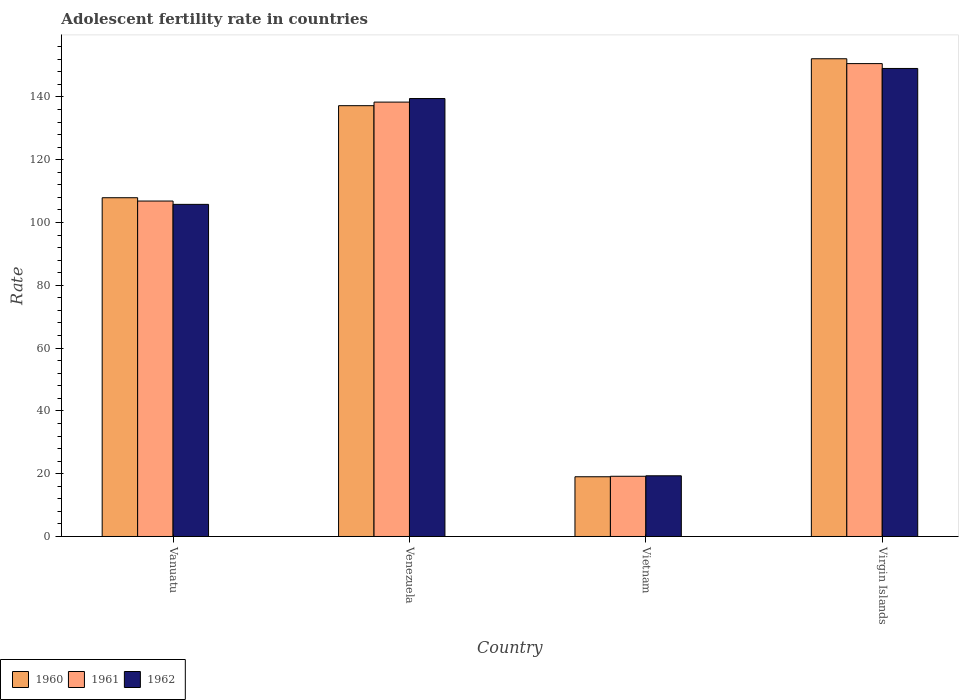How many groups of bars are there?
Provide a succinct answer. 4. How many bars are there on the 2nd tick from the left?
Provide a succinct answer. 3. How many bars are there on the 4th tick from the right?
Your answer should be compact. 3. What is the label of the 1st group of bars from the left?
Keep it short and to the point. Vanuatu. In how many cases, is the number of bars for a given country not equal to the number of legend labels?
Your answer should be very brief. 0. What is the adolescent fertility rate in 1962 in Venezuela?
Give a very brief answer. 139.49. Across all countries, what is the maximum adolescent fertility rate in 1961?
Offer a terse response. 150.61. Across all countries, what is the minimum adolescent fertility rate in 1962?
Offer a terse response. 19.33. In which country was the adolescent fertility rate in 1961 maximum?
Your answer should be compact. Virgin Islands. In which country was the adolescent fertility rate in 1962 minimum?
Provide a succinct answer. Vietnam. What is the total adolescent fertility rate in 1960 in the graph?
Provide a short and direct response. 416.29. What is the difference between the adolescent fertility rate in 1961 in Vanuatu and that in Virgin Islands?
Ensure brevity in your answer.  -43.77. What is the difference between the adolescent fertility rate in 1960 in Venezuela and the adolescent fertility rate in 1962 in Virgin Islands?
Keep it short and to the point. -11.86. What is the average adolescent fertility rate in 1961 per country?
Your answer should be very brief. 103.75. What is the difference between the adolescent fertility rate of/in 1962 and adolescent fertility rate of/in 1961 in Vietnam?
Offer a very short reply. 0.15. What is the ratio of the adolescent fertility rate in 1961 in Vanuatu to that in Venezuela?
Your answer should be very brief. 0.77. Is the adolescent fertility rate in 1960 in Vietnam less than that in Virgin Islands?
Keep it short and to the point. Yes. Is the difference between the adolescent fertility rate in 1962 in Venezuela and Virgin Islands greater than the difference between the adolescent fertility rate in 1961 in Venezuela and Virgin Islands?
Your response must be concise. Yes. What is the difference between the highest and the second highest adolescent fertility rate in 1960?
Provide a short and direct response. 14.94. What is the difference between the highest and the lowest adolescent fertility rate in 1960?
Keep it short and to the point. 133.13. What does the 3rd bar from the left in Vanuatu represents?
Keep it short and to the point. 1962. Is it the case that in every country, the sum of the adolescent fertility rate in 1961 and adolescent fertility rate in 1962 is greater than the adolescent fertility rate in 1960?
Keep it short and to the point. Yes. How many bars are there?
Provide a short and direct response. 12. Are all the bars in the graph horizontal?
Your response must be concise. No. What is the difference between two consecutive major ticks on the Y-axis?
Give a very brief answer. 20. Are the values on the major ticks of Y-axis written in scientific E-notation?
Keep it short and to the point. No. How many legend labels are there?
Your answer should be very brief. 3. How are the legend labels stacked?
Keep it short and to the point. Horizontal. What is the title of the graph?
Ensure brevity in your answer.  Adolescent fertility rate in countries. What is the label or title of the Y-axis?
Provide a short and direct response. Rate. What is the Rate of 1960 in Vanuatu?
Your answer should be very brief. 107.9. What is the Rate of 1961 in Vanuatu?
Give a very brief answer. 106.84. What is the Rate of 1962 in Vanuatu?
Offer a terse response. 105.78. What is the Rate of 1960 in Venezuela?
Your answer should be very brief. 137.21. What is the Rate of 1961 in Venezuela?
Ensure brevity in your answer.  138.35. What is the Rate of 1962 in Venezuela?
Make the answer very short. 139.49. What is the Rate of 1960 in Vietnam?
Provide a succinct answer. 19.03. What is the Rate in 1961 in Vietnam?
Offer a very short reply. 19.18. What is the Rate in 1962 in Vietnam?
Provide a succinct answer. 19.33. What is the Rate of 1960 in Virgin Islands?
Your answer should be compact. 152.16. What is the Rate in 1961 in Virgin Islands?
Give a very brief answer. 150.61. What is the Rate of 1962 in Virgin Islands?
Ensure brevity in your answer.  149.07. Across all countries, what is the maximum Rate in 1960?
Your answer should be compact. 152.16. Across all countries, what is the maximum Rate of 1961?
Ensure brevity in your answer.  150.61. Across all countries, what is the maximum Rate of 1962?
Offer a terse response. 149.07. Across all countries, what is the minimum Rate of 1960?
Your answer should be compact. 19.03. Across all countries, what is the minimum Rate of 1961?
Your answer should be compact. 19.18. Across all countries, what is the minimum Rate in 1962?
Provide a short and direct response. 19.33. What is the total Rate in 1960 in the graph?
Provide a short and direct response. 416.29. What is the total Rate in 1961 in the graph?
Offer a very short reply. 414.98. What is the total Rate in 1962 in the graph?
Offer a terse response. 413.68. What is the difference between the Rate in 1960 in Vanuatu and that in Venezuela?
Ensure brevity in your answer.  -29.32. What is the difference between the Rate of 1961 in Vanuatu and that in Venezuela?
Provide a short and direct response. -31.51. What is the difference between the Rate of 1962 in Vanuatu and that in Venezuela?
Offer a terse response. -33.71. What is the difference between the Rate of 1960 in Vanuatu and that in Vietnam?
Provide a short and direct response. 88.87. What is the difference between the Rate of 1961 in Vanuatu and that in Vietnam?
Give a very brief answer. 87.66. What is the difference between the Rate in 1962 in Vanuatu and that in Vietnam?
Your response must be concise. 86.45. What is the difference between the Rate in 1960 in Vanuatu and that in Virgin Islands?
Offer a very short reply. -44.26. What is the difference between the Rate in 1961 in Vanuatu and that in Virgin Islands?
Offer a very short reply. -43.77. What is the difference between the Rate in 1962 in Vanuatu and that in Virgin Islands?
Make the answer very short. -43.29. What is the difference between the Rate of 1960 in Venezuela and that in Vietnam?
Offer a terse response. 118.19. What is the difference between the Rate in 1961 in Venezuela and that in Vietnam?
Make the answer very short. 119.17. What is the difference between the Rate of 1962 in Venezuela and that in Vietnam?
Provide a succinct answer. 120.16. What is the difference between the Rate in 1960 in Venezuela and that in Virgin Islands?
Provide a short and direct response. -14.95. What is the difference between the Rate in 1961 in Venezuela and that in Virgin Islands?
Your answer should be compact. -12.26. What is the difference between the Rate of 1962 in Venezuela and that in Virgin Islands?
Your answer should be very brief. -9.58. What is the difference between the Rate in 1960 in Vietnam and that in Virgin Islands?
Give a very brief answer. -133.13. What is the difference between the Rate of 1961 in Vietnam and that in Virgin Islands?
Keep it short and to the point. -131.44. What is the difference between the Rate in 1962 in Vietnam and that in Virgin Islands?
Give a very brief answer. -129.74. What is the difference between the Rate in 1960 in Vanuatu and the Rate in 1961 in Venezuela?
Offer a very short reply. -30.45. What is the difference between the Rate in 1960 in Vanuatu and the Rate in 1962 in Venezuela?
Provide a succinct answer. -31.59. What is the difference between the Rate of 1961 in Vanuatu and the Rate of 1962 in Venezuela?
Offer a very short reply. -32.65. What is the difference between the Rate of 1960 in Vanuatu and the Rate of 1961 in Vietnam?
Offer a terse response. 88.72. What is the difference between the Rate in 1960 in Vanuatu and the Rate in 1962 in Vietnam?
Your answer should be compact. 88.57. What is the difference between the Rate in 1961 in Vanuatu and the Rate in 1962 in Vietnam?
Give a very brief answer. 87.51. What is the difference between the Rate in 1960 in Vanuatu and the Rate in 1961 in Virgin Islands?
Offer a terse response. -42.72. What is the difference between the Rate in 1960 in Vanuatu and the Rate in 1962 in Virgin Islands?
Offer a very short reply. -41.17. What is the difference between the Rate of 1961 in Vanuatu and the Rate of 1962 in Virgin Islands?
Provide a short and direct response. -42.23. What is the difference between the Rate in 1960 in Venezuela and the Rate in 1961 in Vietnam?
Make the answer very short. 118.03. What is the difference between the Rate in 1960 in Venezuela and the Rate in 1962 in Vietnam?
Keep it short and to the point. 117.88. What is the difference between the Rate in 1961 in Venezuela and the Rate in 1962 in Vietnam?
Make the answer very short. 119.02. What is the difference between the Rate in 1960 in Venezuela and the Rate in 1961 in Virgin Islands?
Give a very brief answer. -13.4. What is the difference between the Rate of 1960 in Venezuela and the Rate of 1962 in Virgin Islands?
Offer a very short reply. -11.86. What is the difference between the Rate in 1961 in Venezuela and the Rate in 1962 in Virgin Islands?
Your answer should be very brief. -10.72. What is the difference between the Rate of 1960 in Vietnam and the Rate of 1961 in Virgin Islands?
Offer a very short reply. -131.59. What is the difference between the Rate in 1960 in Vietnam and the Rate in 1962 in Virgin Islands?
Offer a very short reply. -130.04. What is the difference between the Rate in 1961 in Vietnam and the Rate in 1962 in Virgin Islands?
Provide a short and direct response. -129.89. What is the average Rate of 1960 per country?
Offer a terse response. 104.07. What is the average Rate in 1961 per country?
Ensure brevity in your answer.  103.75. What is the average Rate of 1962 per country?
Keep it short and to the point. 103.42. What is the difference between the Rate of 1960 and Rate of 1961 in Vanuatu?
Keep it short and to the point. 1.06. What is the difference between the Rate of 1960 and Rate of 1962 in Vanuatu?
Provide a short and direct response. 2.12. What is the difference between the Rate of 1961 and Rate of 1962 in Vanuatu?
Provide a short and direct response. 1.06. What is the difference between the Rate in 1960 and Rate in 1961 in Venezuela?
Your answer should be very brief. -1.14. What is the difference between the Rate of 1960 and Rate of 1962 in Venezuela?
Your answer should be very brief. -2.28. What is the difference between the Rate in 1961 and Rate in 1962 in Venezuela?
Your answer should be compact. -1.14. What is the difference between the Rate in 1960 and Rate in 1961 in Vietnam?
Provide a succinct answer. -0.15. What is the difference between the Rate in 1960 and Rate in 1962 in Vietnam?
Make the answer very short. -0.31. What is the difference between the Rate of 1961 and Rate of 1962 in Vietnam?
Make the answer very short. -0.15. What is the difference between the Rate of 1960 and Rate of 1961 in Virgin Islands?
Offer a terse response. 1.54. What is the difference between the Rate of 1960 and Rate of 1962 in Virgin Islands?
Keep it short and to the point. 3.09. What is the difference between the Rate of 1961 and Rate of 1962 in Virgin Islands?
Keep it short and to the point. 1.54. What is the ratio of the Rate in 1960 in Vanuatu to that in Venezuela?
Offer a very short reply. 0.79. What is the ratio of the Rate of 1961 in Vanuatu to that in Venezuela?
Your response must be concise. 0.77. What is the ratio of the Rate of 1962 in Vanuatu to that in Venezuela?
Ensure brevity in your answer.  0.76. What is the ratio of the Rate of 1960 in Vanuatu to that in Vietnam?
Your answer should be very brief. 5.67. What is the ratio of the Rate in 1961 in Vanuatu to that in Vietnam?
Provide a succinct answer. 5.57. What is the ratio of the Rate of 1962 in Vanuatu to that in Vietnam?
Give a very brief answer. 5.47. What is the ratio of the Rate in 1960 in Vanuatu to that in Virgin Islands?
Offer a very short reply. 0.71. What is the ratio of the Rate of 1961 in Vanuatu to that in Virgin Islands?
Provide a short and direct response. 0.71. What is the ratio of the Rate in 1962 in Vanuatu to that in Virgin Islands?
Offer a very short reply. 0.71. What is the ratio of the Rate of 1960 in Venezuela to that in Vietnam?
Provide a succinct answer. 7.21. What is the ratio of the Rate in 1961 in Venezuela to that in Vietnam?
Provide a short and direct response. 7.21. What is the ratio of the Rate in 1962 in Venezuela to that in Vietnam?
Ensure brevity in your answer.  7.22. What is the ratio of the Rate in 1960 in Venezuela to that in Virgin Islands?
Give a very brief answer. 0.9. What is the ratio of the Rate of 1961 in Venezuela to that in Virgin Islands?
Offer a very short reply. 0.92. What is the ratio of the Rate in 1962 in Venezuela to that in Virgin Islands?
Ensure brevity in your answer.  0.94. What is the ratio of the Rate in 1960 in Vietnam to that in Virgin Islands?
Provide a short and direct response. 0.12. What is the ratio of the Rate in 1961 in Vietnam to that in Virgin Islands?
Provide a short and direct response. 0.13. What is the ratio of the Rate in 1962 in Vietnam to that in Virgin Islands?
Keep it short and to the point. 0.13. What is the difference between the highest and the second highest Rate in 1960?
Provide a succinct answer. 14.95. What is the difference between the highest and the second highest Rate of 1961?
Keep it short and to the point. 12.26. What is the difference between the highest and the second highest Rate in 1962?
Provide a succinct answer. 9.58. What is the difference between the highest and the lowest Rate of 1960?
Your response must be concise. 133.13. What is the difference between the highest and the lowest Rate of 1961?
Ensure brevity in your answer.  131.44. What is the difference between the highest and the lowest Rate of 1962?
Offer a terse response. 129.74. 